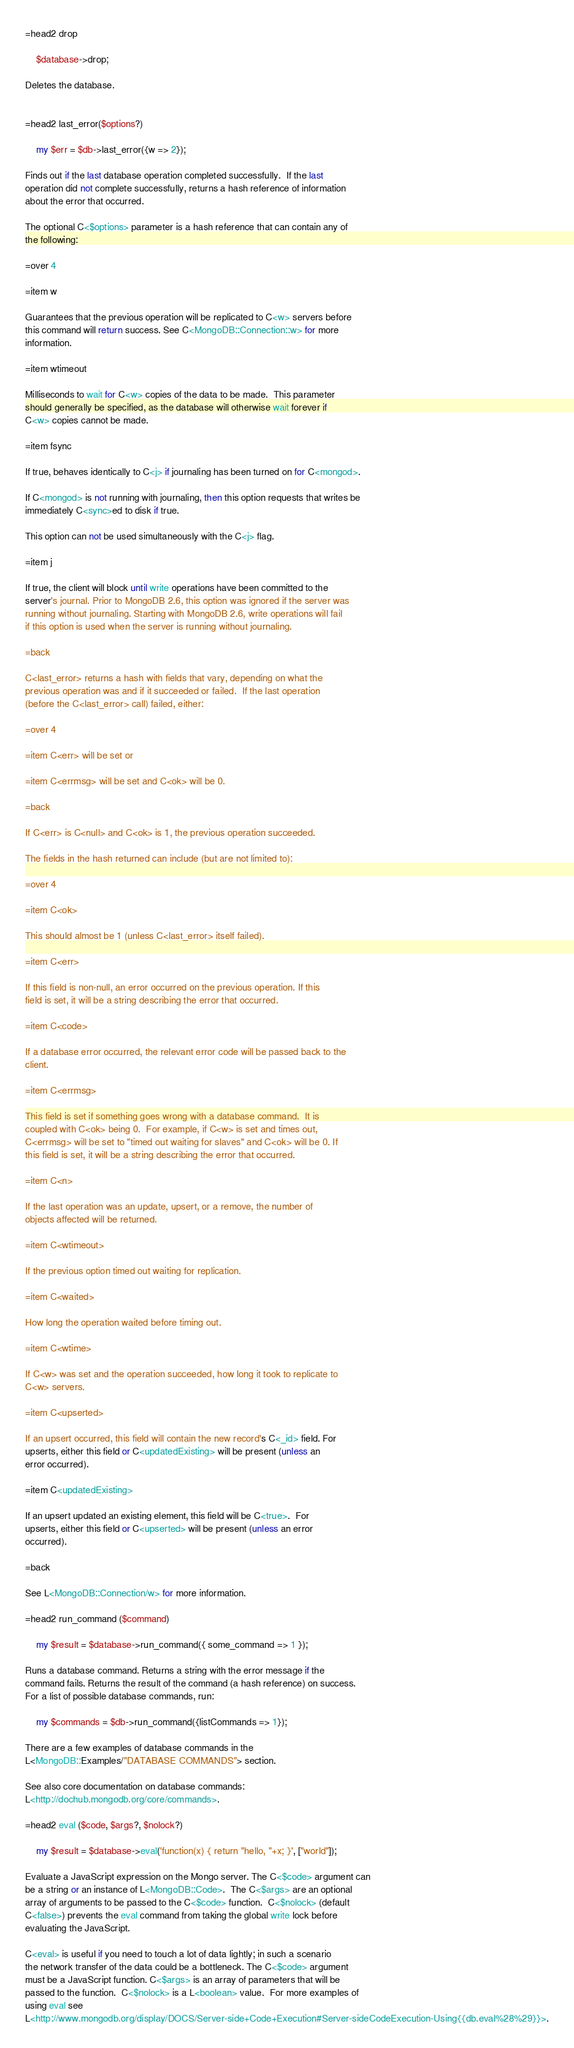Convert code to text. <code><loc_0><loc_0><loc_500><loc_500><_Perl_>
=head2 drop

    $database->drop;

Deletes the database.


=head2 last_error($options?)

    my $err = $db->last_error({w => 2});

Finds out if the last database operation completed successfully.  If the last
operation did not complete successfully, returns a hash reference of information
about the error that occurred.

The optional C<$options> parameter is a hash reference that can contain any of
the following:

=over 4

=item w

Guarantees that the previous operation will be replicated to C<w> servers before
this command will return success. See C<MongoDB::Connection::w> for more
information.

=item wtimeout

Milliseconds to wait for C<w> copies of the data to be made.  This parameter
should generally be specified, as the database will otherwise wait forever if
C<w> copies cannot be made.

=item fsync

If true, behaves identically to C<j> if journaling has been turned on for C<mongod>. 

If C<mongod> is not running with journaling, then this option requests that writes be 
immediately C<sync>ed to disk if true.

This option can not be used simultaneously with the C<j> flag.

=item j

If true, the client will block until write operations have been committed to the
server's journal. Prior to MongoDB 2.6, this option was ignored if the server was 
running without journaling. Starting with MongoDB 2.6, write operations will fail 
if this option is used when the server is running without journaling.

=back

C<last_error> returns a hash with fields that vary, depending on what the
previous operation was and if it succeeded or failed.  If the last operation
(before the C<last_error> call) failed, either:

=over 4

=item C<err> will be set or

=item C<errmsg> will be set and C<ok> will be 0.

=back

If C<err> is C<null> and C<ok> is 1, the previous operation succeeded.

The fields in the hash returned can include (but are not limited to):

=over 4

=item C<ok>

This should almost be 1 (unless C<last_error> itself failed).

=item C<err>

If this field is non-null, an error occurred on the previous operation. If this
field is set, it will be a string describing the error that occurred.

=item C<code>

If a database error occurred, the relevant error code will be passed back to the
client.

=item C<errmsg>

This field is set if something goes wrong with a database command.  It is
coupled with C<ok> being 0.  For example, if C<w> is set and times out,
C<errmsg> will be set to "timed out waiting for slaves" and C<ok> will be 0. If
this field is set, it will be a string describing the error that occurred.

=item C<n>

If the last operation was an update, upsert, or a remove, the number of
objects affected will be returned.

=item C<wtimeout>

If the previous option timed out waiting for replication.

=item C<waited>

How long the operation waited before timing out.

=item C<wtime>

If C<w> was set and the operation succeeded, how long it took to replicate to
C<w> servers.

=item C<upserted>

If an upsert occurred, this field will contain the new record's C<_id> field. For
upserts, either this field or C<updatedExisting> will be present (unless an
error occurred).

=item C<updatedExisting>

If an upsert updated an existing element, this field will be C<true>.  For
upserts, either this field or C<upserted> will be present (unless an error
occurred).

=back

See L<MongoDB::Connection/w> for more information.

=head2 run_command ($command)

    my $result = $database->run_command({ some_command => 1 });

Runs a database command. Returns a string with the error message if the
command fails. Returns the result of the command (a hash reference) on success.
For a list of possible database commands, run:

    my $commands = $db->run_command({listCommands => 1});

There are a few examples of database commands in the
L<MongoDB::Examples/"DATABASE COMMANDS"> section.

See also core documentation on database commands:
L<http://dochub.mongodb.org/core/commands>.

=head2 eval ($code, $args?, $nolock?)

    my $result = $database->eval('function(x) { return "hello, "+x; }', ["world"]);

Evaluate a JavaScript expression on the Mongo server. The C<$code> argument can
be a string or an instance of L<MongoDB::Code>.  The C<$args> are an optional
array of arguments to be passed to the C<$code> function.  C<$nolock> (default
C<false>) prevents the eval command from taking the global write lock before
evaluating the JavaScript.

C<eval> is useful if you need to touch a lot of data lightly; in such a scenario
the network transfer of the data could be a bottleneck. The C<$code> argument
must be a JavaScript function. C<$args> is an array of parameters that will be
passed to the function.  C<$nolock> is a L<boolean> value.  For more examples of
using eval see
L<http://www.mongodb.org/display/DOCS/Server-side+Code+Execution#Server-sideCodeExecution-Using{{db.eval%28%29}}>.



</code> 